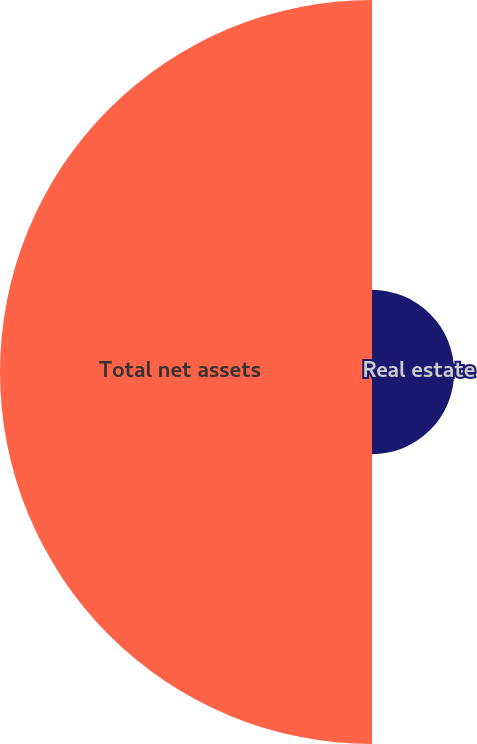<chart> <loc_0><loc_0><loc_500><loc_500><pie_chart><fcel>Real estate<fcel>Total net assets<nl><fcel>18.09%<fcel>81.91%<nl></chart> 